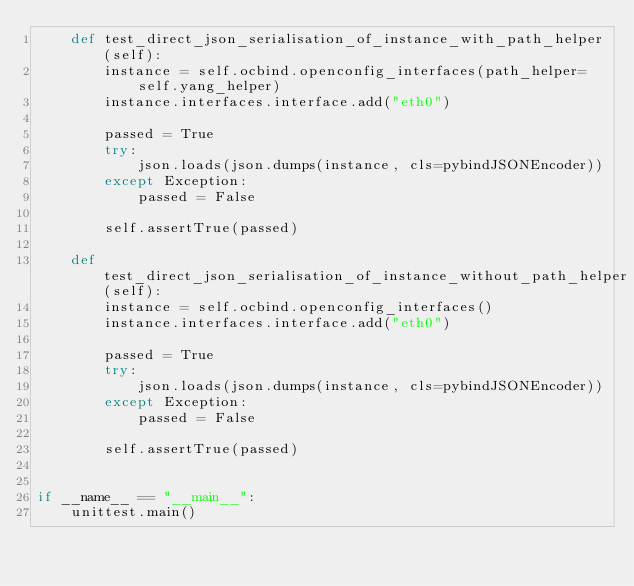Convert code to text. <code><loc_0><loc_0><loc_500><loc_500><_Python_>    def test_direct_json_serialisation_of_instance_with_path_helper(self):
        instance = self.ocbind.openconfig_interfaces(path_helper=self.yang_helper)
        instance.interfaces.interface.add("eth0")

        passed = True
        try:
            json.loads(json.dumps(instance, cls=pybindJSONEncoder))
        except Exception:
            passed = False

        self.assertTrue(passed)

    def test_direct_json_serialisation_of_instance_without_path_helper(self):
        instance = self.ocbind.openconfig_interfaces()
        instance.interfaces.interface.add("eth0")

        passed = True
        try:
            json.loads(json.dumps(instance, cls=pybindJSONEncoder))
        except Exception:
            passed = False

        self.assertTrue(passed)


if __name__ == "__main__":
    unittest.main()
</code> 